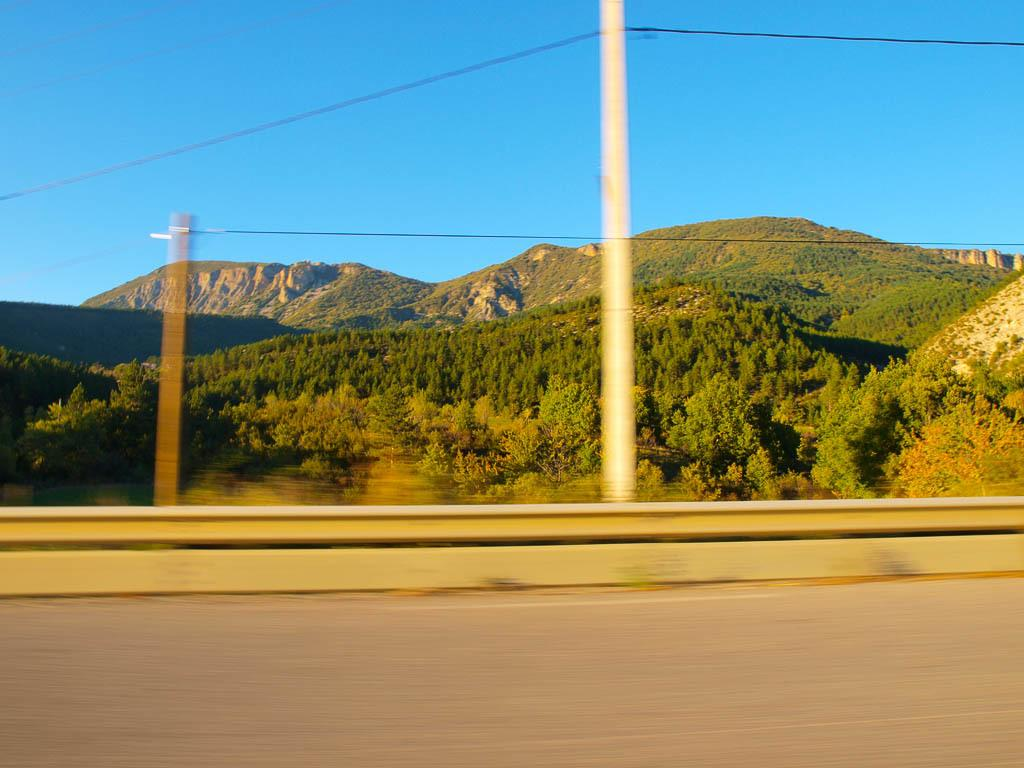What type of vegetation can be seen in the image? There are trees in the image. What structures are present in the image? There are poles in the image. What color is the sky in the image? The sky is blue in the image. What type of comfort can be seen in the image? There is no reference to comfort in the image; it features trees, poles, and a blue sky. What type of business is being conducted in the image? There is no indication of any business activity in the image. 